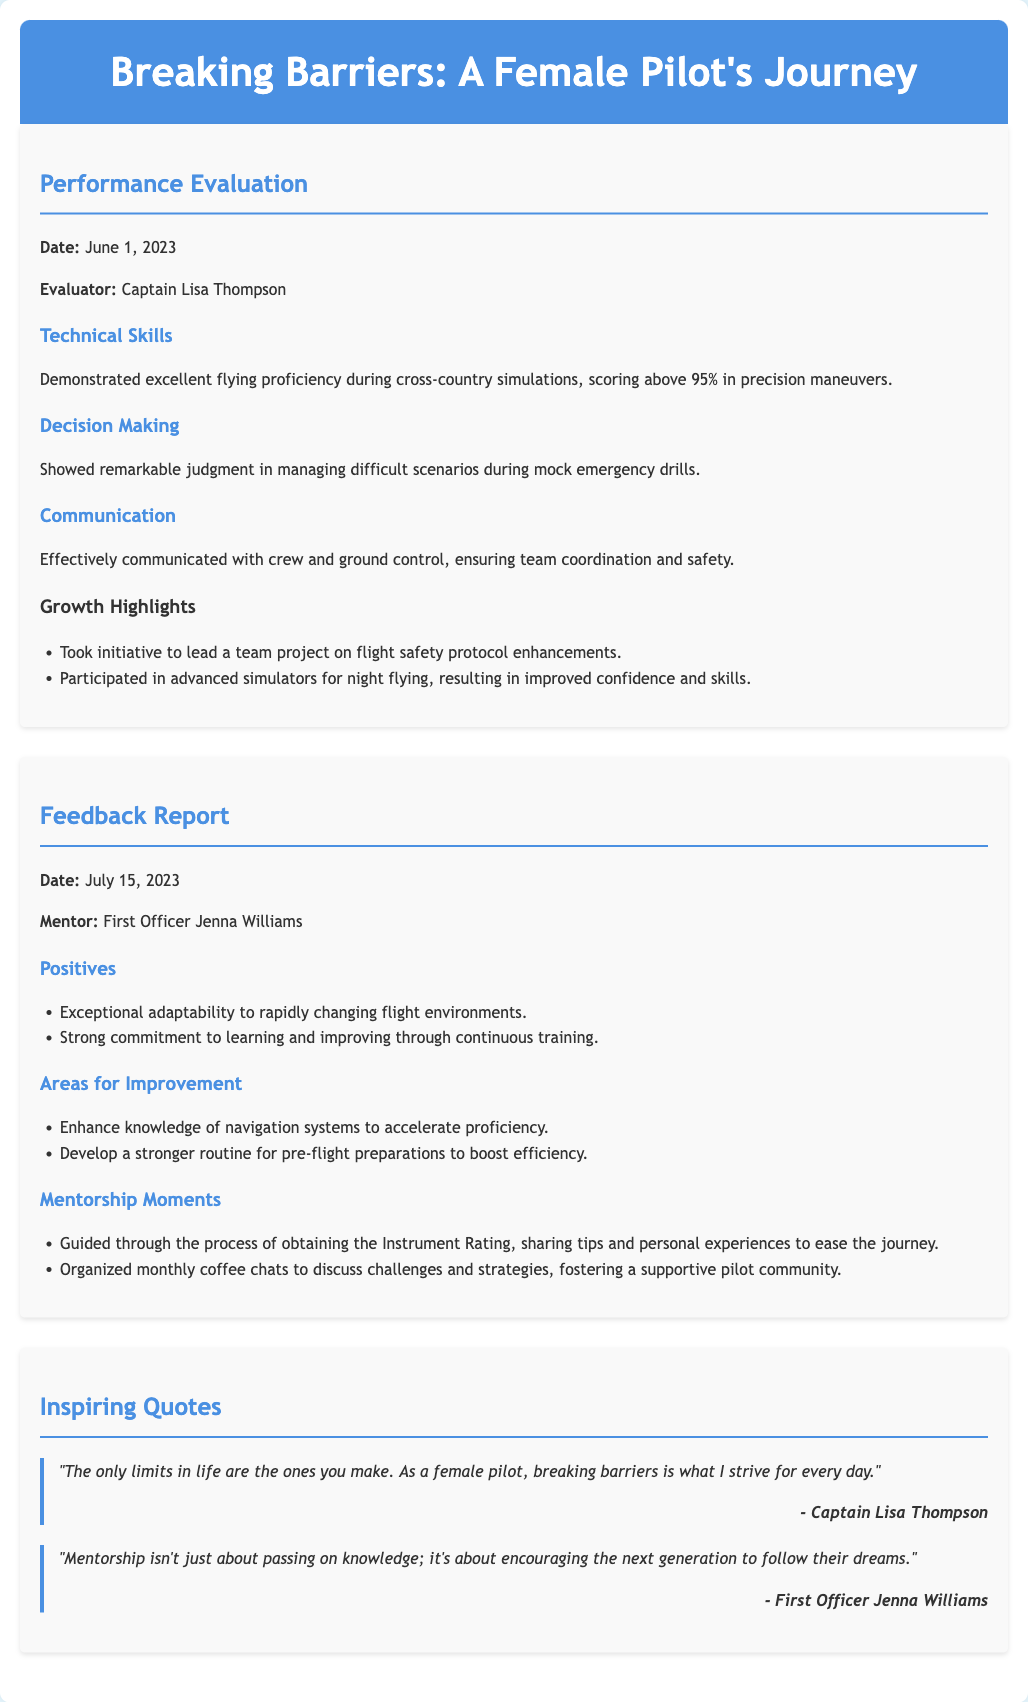What is the date of the performance evaluation? The performance evaluation date is explicitly mentioned in the document.
Answer: June 1, 2023 Who evaluated the performance? The evaluator's name is listed in the performance evaluation section of the document.
Answer: Captain Lisa Thompson What percentage was scored in precision maneuvers? The document provides specific performance metrics related to technical skills.
Answer: 95% What is one area for improvement mentioned? The feedback report outlines areas that need enhancement, which can be identified from the text.
Answer: Enhance knowledge of navigation systems Who provided mentorship in the feedback report? The mentor's name is indicated in the feedback report section.
Answer: First Officer Jenna Williams What is one positive feedback given? The positives section of the feedback report includes commendations for the pilot's skills.
Answer: Exceptional adaptability What event is highlighted under Growth Highlights? Growth highlights are listed in the performance evaluation, which can be specifically identified.
Answer: Lead a team project on flight safety protocol enhancements How often were the coffee chats organized? The mentorship moments provide insight into the regularity of support meetings.
Answer: Monthly What inspiring quote is attributed to Captain Lisa Thompson? The quotes section includes impactful sayings from both pilots, which can be directly quoted.
Answer: "The only limits in life are the ones you make. As a female pilot, breaking barriers is what I strive for every day." 